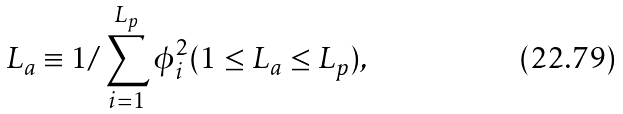<formula> <loc_0><loc_0><loc_500><loc_500>L _ { a } \equiv 1 / \sum _ { i = 1 } ^ { L _ { p } } \phi _ { i } ^ { 2 } ( 1 \leq L _ { a } \leq L _ { p } ) ,</formula> 